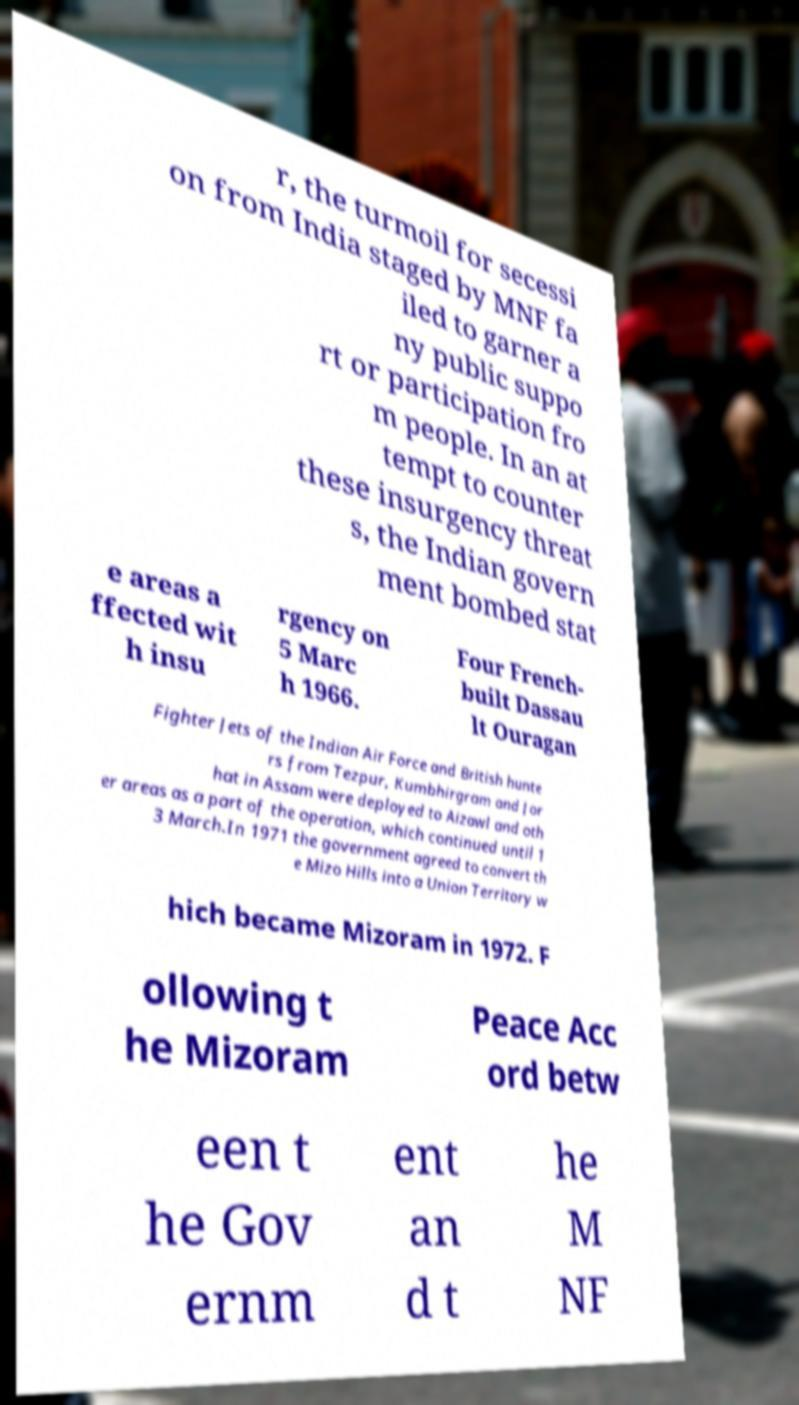Could you assist in decoding the text presented in this image and type it out clearly? r, the turmoil for secessi on from India staged by MNF fa iled to garner a ny public suppo rt or participation fro m people. In an at tempt to counter these insurgency threat s, the Indian govern ment bombed stat e areas a ffected wit h insu rgency on 5 Marc h 1966. Four French- built Dassau lt Ouragan Fighter Jets of the Indian Air Force and British hunte rs from Tezpur, Kumbhirgram and Jor hat in Assam were deployed to Aizawl and oth er areas as a part of the operation, which continued until 1 3 March.In 1971 the government agreed to convert th e Mizo Hills into a Union Territory w hich became Mizoram in 1972. F ollowing t he Mizoram Peace Acc ord betw een t he Gov ernm ent an d t he M NF 